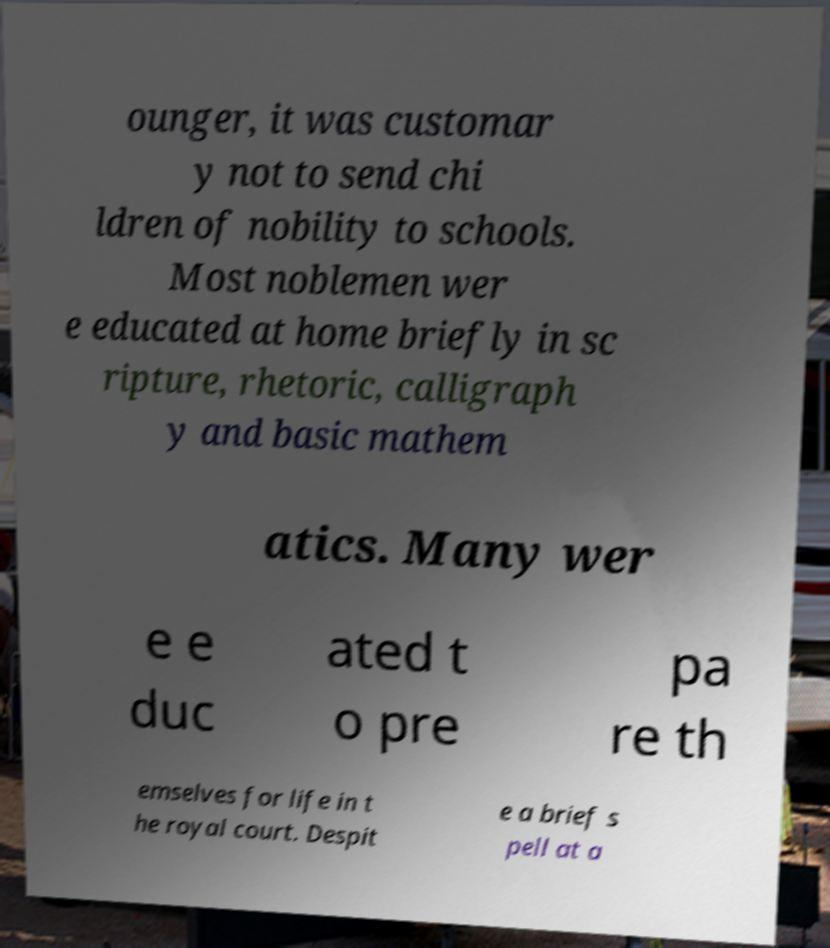Can you read and provide the text displayed in the image?This photo seems to have some interesting text. Can you extract and type it out for me? ounger, it was customar y not to send chi ldren of nobility to schools. Most noblemen wer e educated at home briefly in sc ripture, rhetoric, calligraph y and basic mathem atics. Many wer e e duc ated t o pre pa re th emselves for life in t he royal court. Despit e a brief s pell at a 